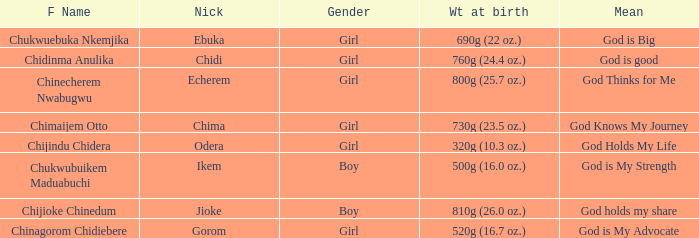How much did the baby who name means God knows my journey weigh at birth? 730g (23.5 oz.). 